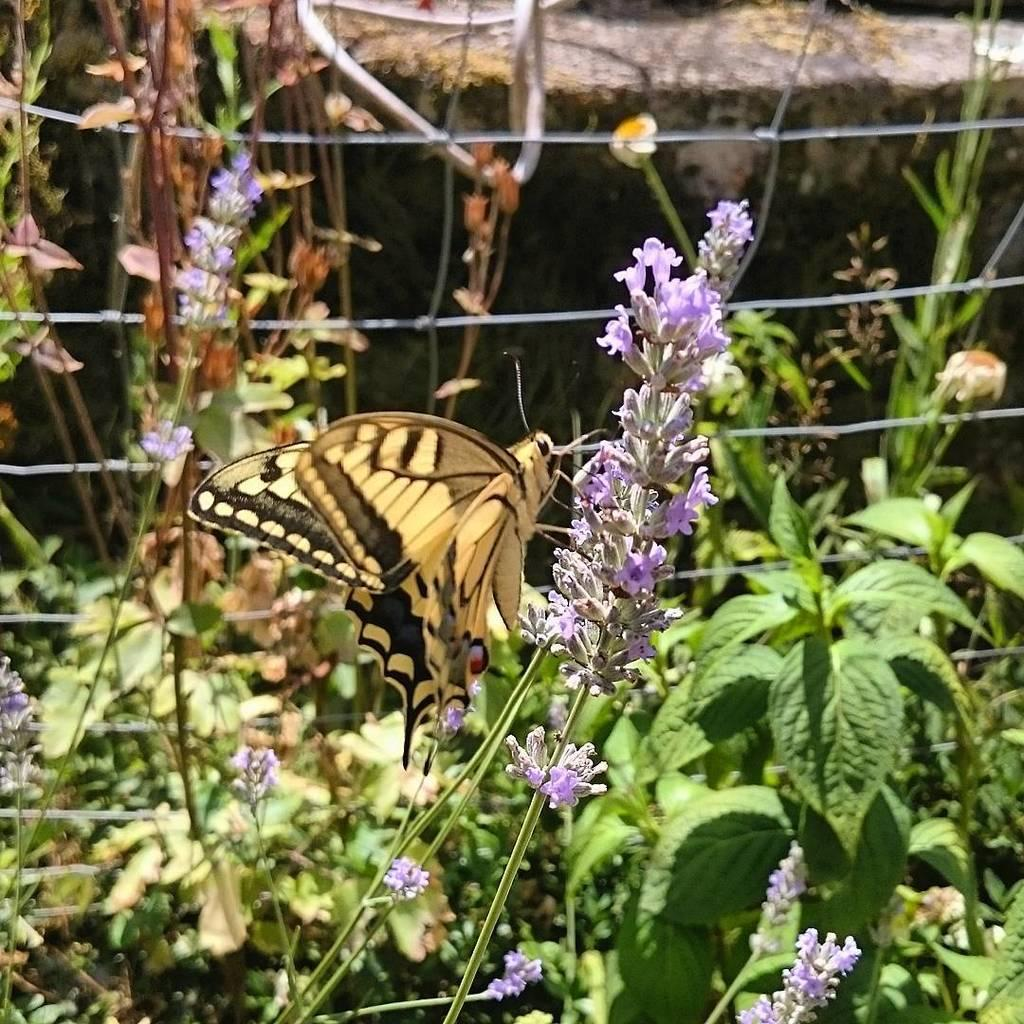What type of living organisms can be seen in the image? Plants can be seen in the image. Where are some of the plants located? Some plants are on a fence in the image. What additional feature can be observed on some of the plants? There are plants with flowers in the image. Can you describe any other living organisms in the image? Yes, there is a butterfly on a flower in the image. What objects are present on a surface in the image? The facts do not specify the objects on the surface, but we can see that there are objects present. What type of wrench is being used to fix the clock in the image? There is no wrench or clock present in the image; it features plants, flowers, and a butterfly. Can you tell me how many dogs are visible in the image? There are no dogs present in the image. 